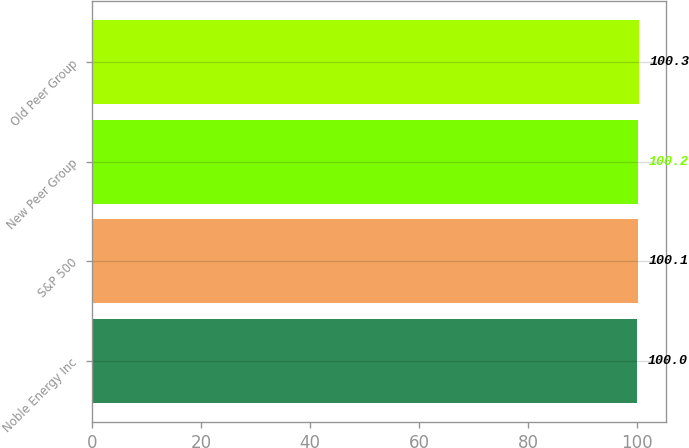Convert chart. <chart><loc_0><loc_0><loc_500><loc_500><bar_chart><fcel>Noble Energy Inc<fcel>S&P 500<fcel>New Peer Group<fcel>Old Peer Group<nl><fcel>100<fcel>100.1<fcel>100.2<fcel>100.3<nl></chart> 